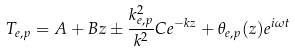Convert formula to latex. <formula><loc_0><loc_0><loc_500><loc_500>T _ { e , p } = A + B z \pm \frac { k ^ { 2 } _ { e , p } } { k ^ { 2 } } C e ^ { - k z } + \theta _ { e , p } ( z ) e ^ { i \omega t }</formula> 